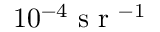Convert formula to latex. <formula><loc_0><loc_0><loc_500><loc_500>1 0 ^ { - 4 } s r ^ { - 1 }</formula> 